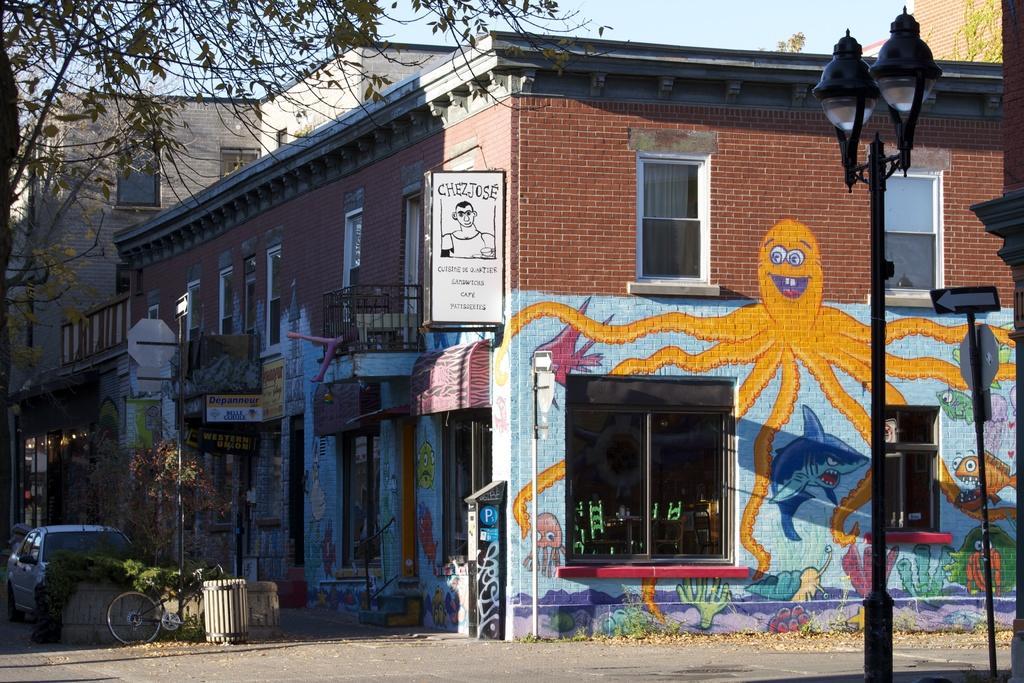How would you summarize this image in a sentence or two? In the center of the image we can see the sky,trees,buildings,windows,banners,sign boards,poles,fences,one dustbin,plants,vehicles,lights and few other objects. And we can see some paintings on the wall. 